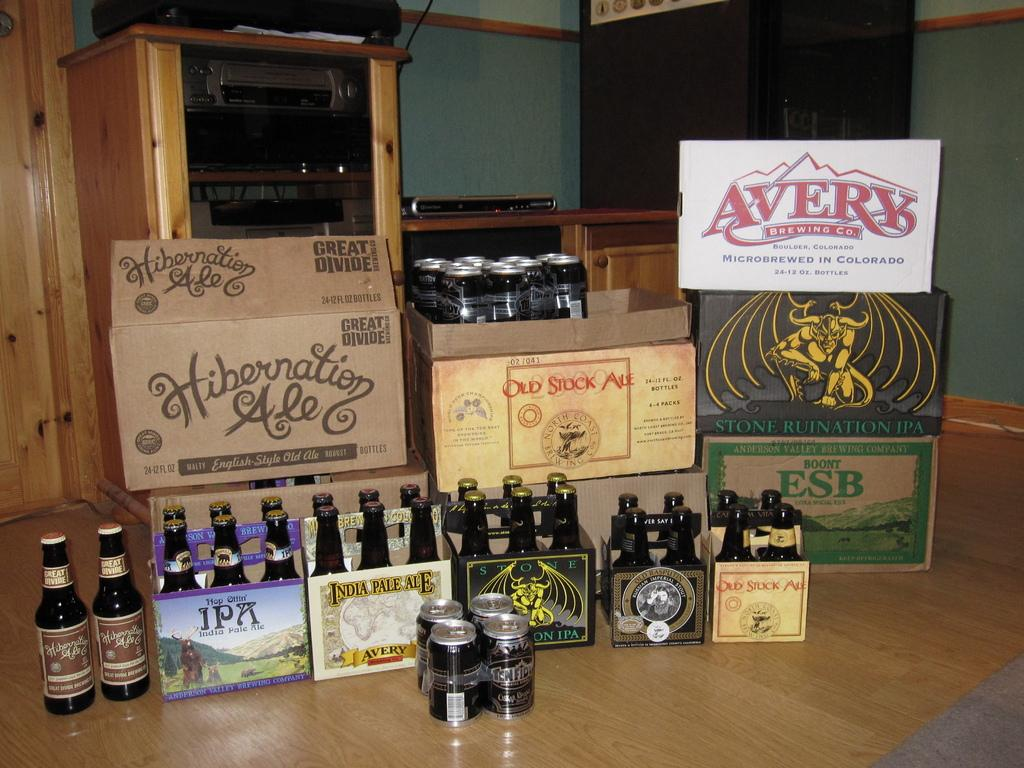<image>
Offer a succinct explanation of the picture presented. A box of Hibernation Ale sits with some other boxes of beer and six packs. 